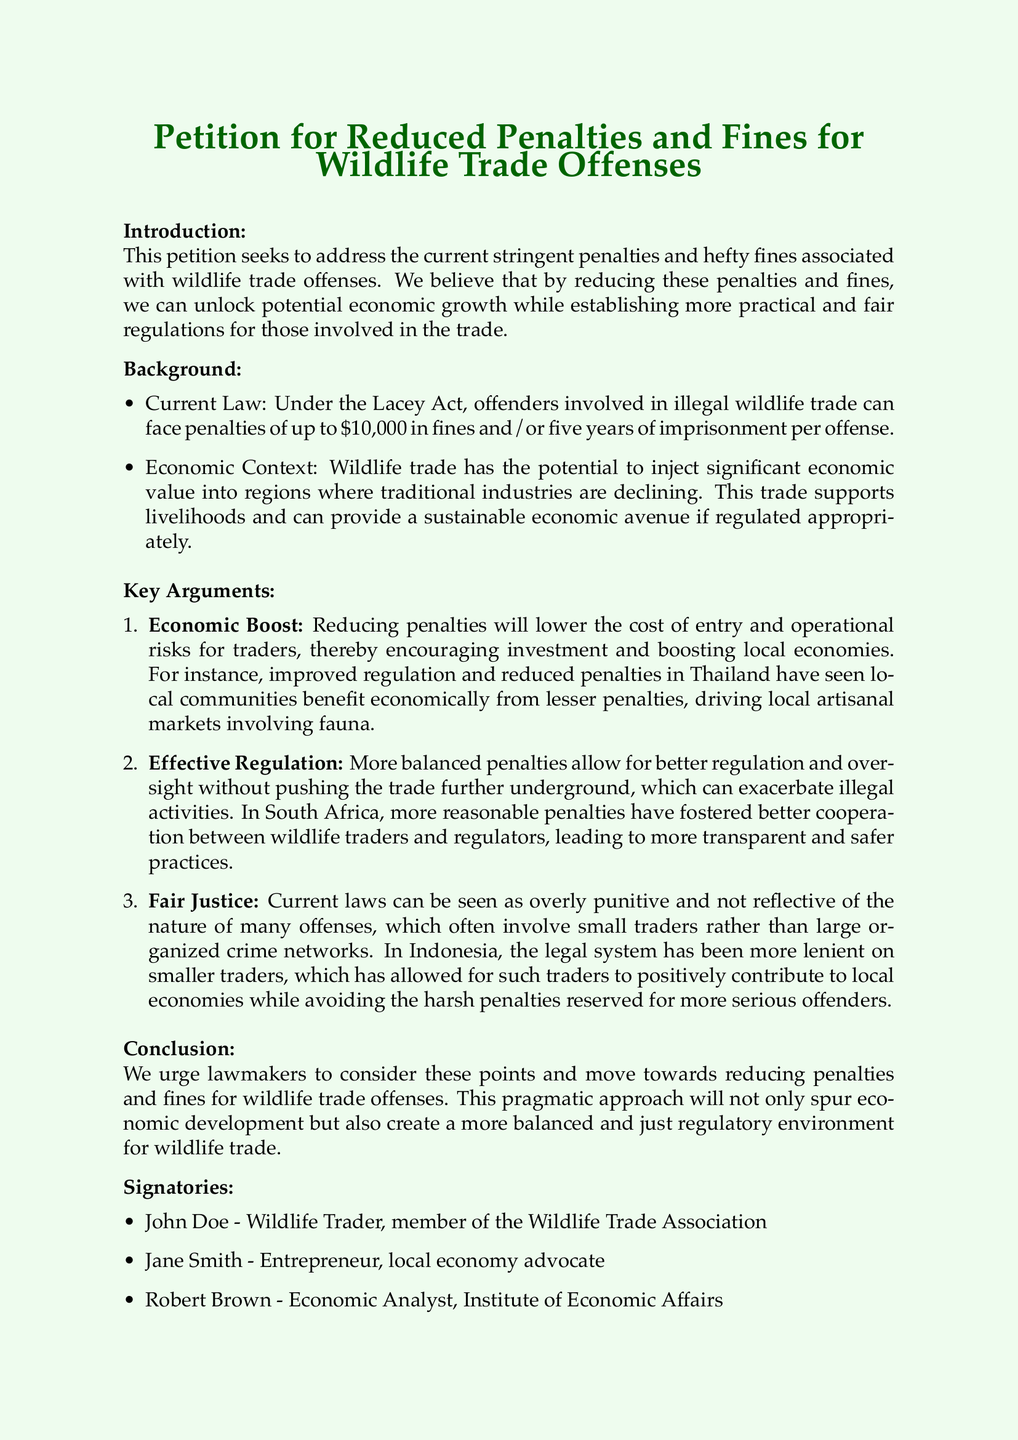What is the title of the petition? The title of the petition is prominently displayed at the top of the document.
Answer: Petition for Reduced Penalties and Fines for Wildlife Trade Offenses What is the maximum penalty under the Lacey Act? The document explicitly states the maximum penalties outlined under the Lacey Act.
Answer: $10,000 How many years of imprisonment can offenders face? The document specifies the potential imprisonment duration for wildlife trade offenses.
Answer: five years What is one example of economic benefit mentioned? The document provides a specific example of how reduced penalties contribute to local economies.
Answer: Thailand Which country is mentioned for better cooperation between traders and regulators? The document references a country where reasonable penalties have fostered cooperation in wildlife trade.
Answer: South Africa How many signatories are listed in the document? The document provides a count of individuals who have signed the petition.
Answer: three What is the position of John Doe? The document specifies John Doe's profession and affiliation in the signatories section.
Answer: Wildlife Trader What is the purpose of reducing penalties according to the petition? The petition articulates a general goal behind reducing penalties and fines associated with wildlife trade.
Answer: Economic growth 